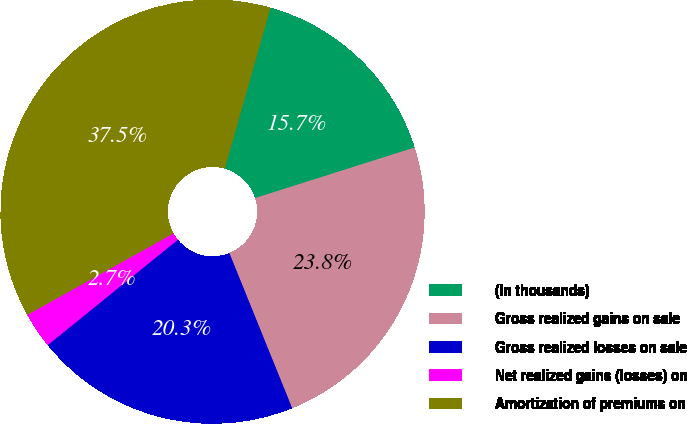Convert chart. <chart><loc_0><loc_0><loc_500><loc_500><pie_chart><fcel>(In thousands)<fcel>Gross realized gains on sale<fcel>Gross realized losses on sale<fcel>Net realized gains (losses) on<fcel>Amortization of premiums on<nl><fcel>15.71%<fcel>23.76%<fcel>20.29%<fcel>2.74%<fcel>37.49%<nl></chart> 